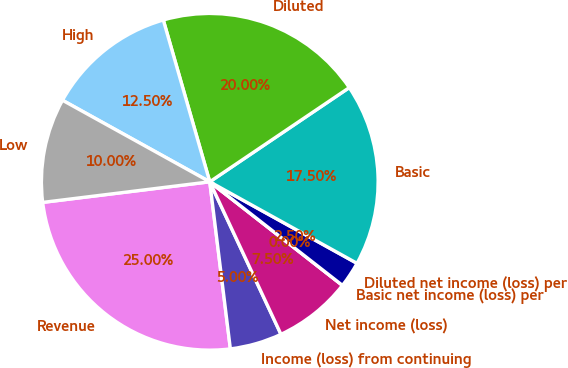Convert chart. <chart><loc_0><loc_0><loc_500><loc_500><pie_chart><fcel>Revenue<fcel>Income (loss) from continuing<fcel>Net income (loss)<fcel>Basic net income (loss) per<fcel>Diluted net income (loss) per<fcel>Basic<fcel>Diluted<fcel>High<fcel>Low<nl><fcel>25.0%<fcel>5.0%<fcel>7.5%<fcel>0.0%<fcel>2.5%<fcel>17.5%<fcel>20.0%<fcel>12.5%<fcel>10.0%<nl></chart> 